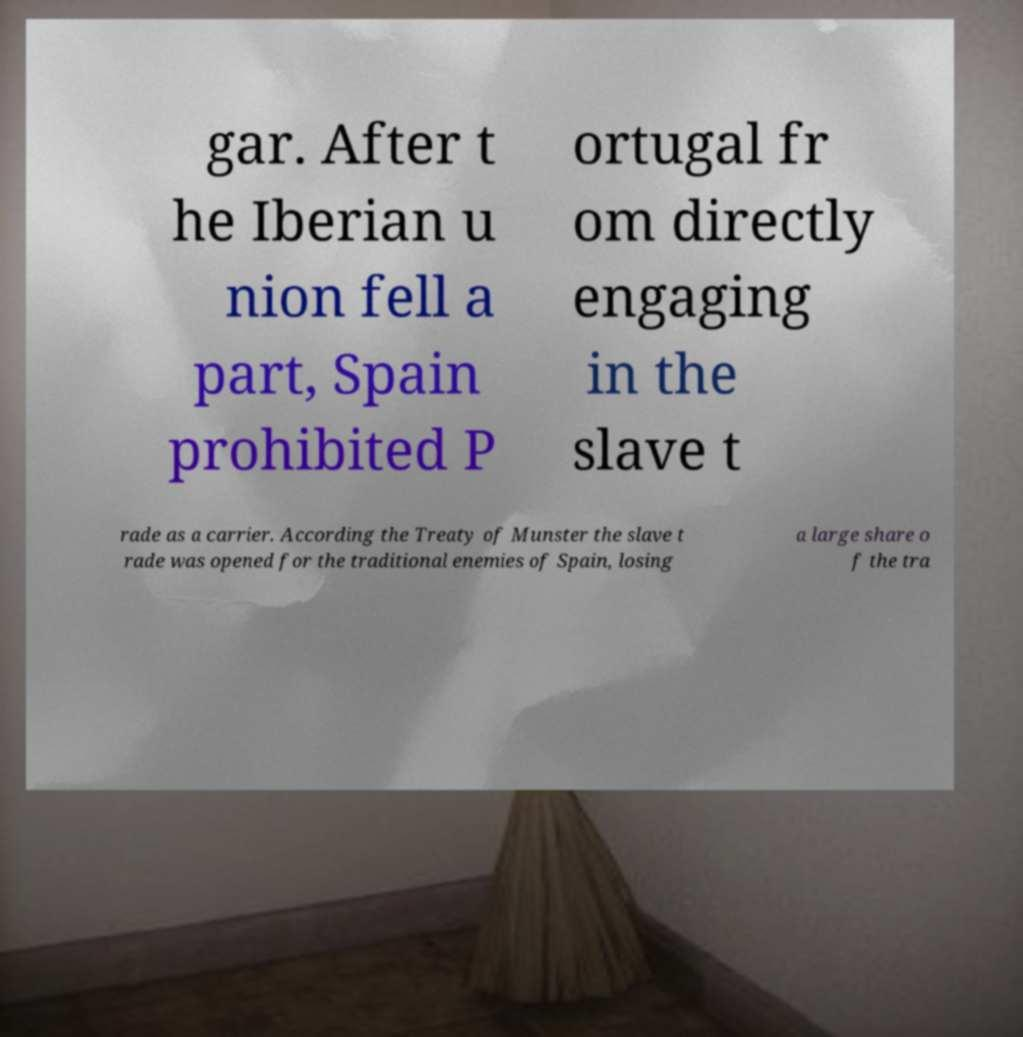Can you accurately transcribe the text from the provided image for me? gar. After t he Iberian u nion fell a part, Spain prohibited P ortugal fr om directly engaging in the slave t rade as a carrier. According the Treaty of Munster the slave t rade was opened for the traditional enemies of Spain, losing a large share o f the tra 